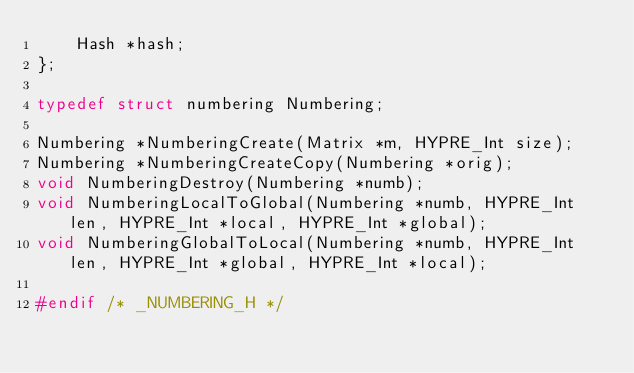<code> <loc_0><loc_0><loc_500><loc_500><_C_>    Hash *hash;
};

typedef struct numbering Numbering;

Numbering *NumberingCreate(Matrix *m, HYPRE_Int size);
Numbering *NumberingCreateCopy(Numbering *orig);
void NumberingDestroy(Numbering *numb);
void NumberingLocalToGlobal(Numbering *numb, HYPRE_Int len, HYPRE_Int *local, HYPRE_Int *global);
void NumberingGlobalToLocal(Numbering *numb, HYPRE_Int len, HYPRE_Int *global, HYPRE_Int *local);

#endif /* _NUMBERING_H */
</code> 